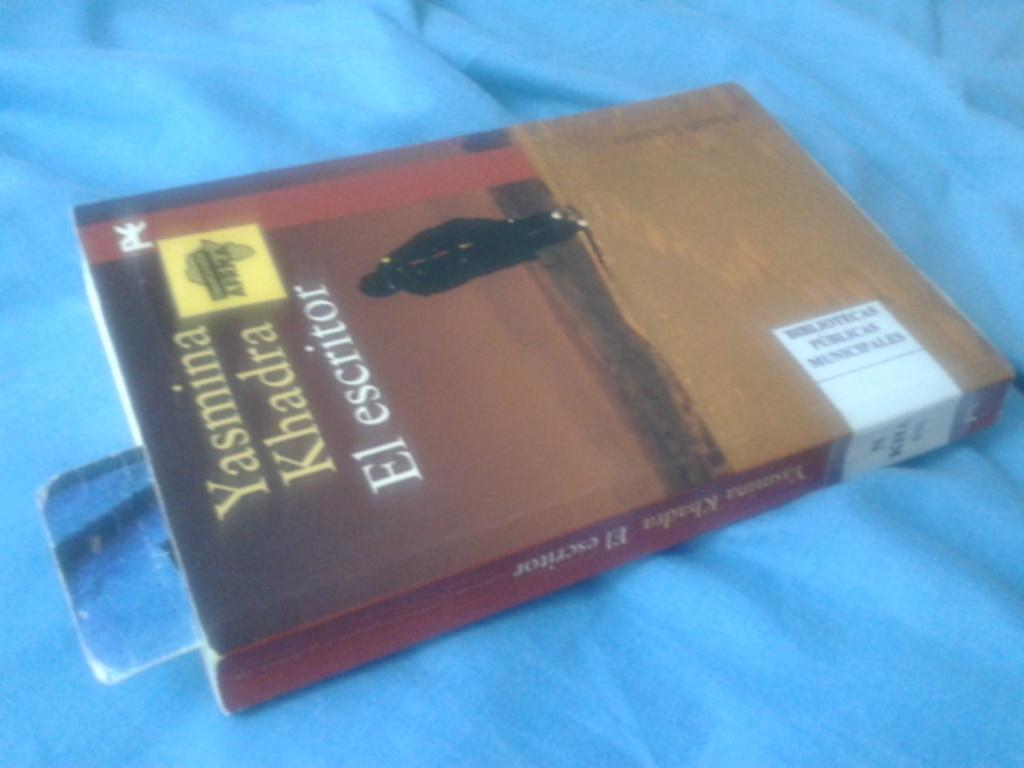<image>
Create a compact narrative representing the image presented. El Escritor was written by Yasmina Khadra and is available now. 